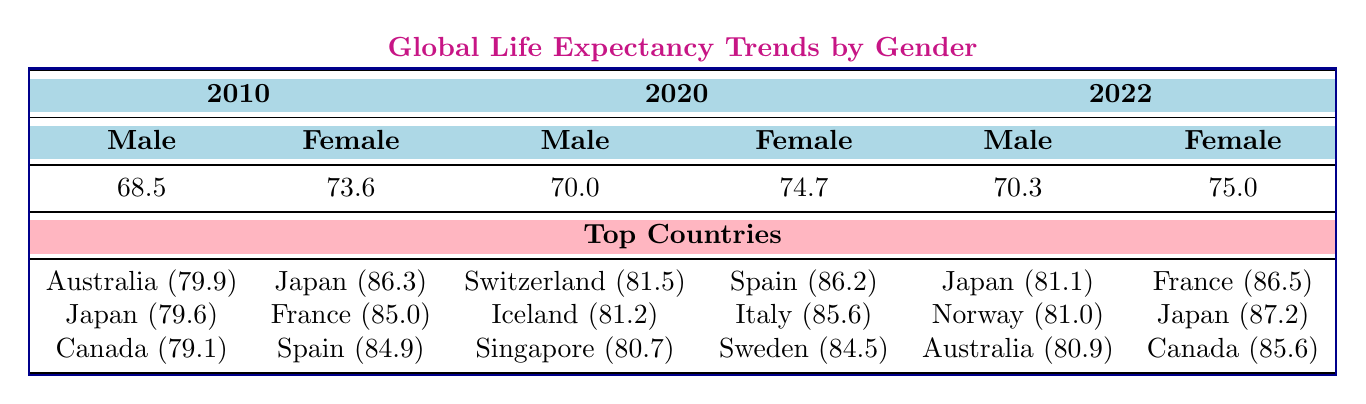What was the average life expectancy for males in 2020? Referring to the table, the value for average life expectancy for males in 2020 is 70.0.
Answer: 70.0 Which country had the highest life expectancy for females in 2022? Checking the top countries for females in 2022 from the table, Japan had the highest life expectancy of 87.2.
Answer: Japan What is the difference in average life expectancy between males and females in 2010? In 2010, the average life expectancy for males is 68.5 and for females is 73.6. The difference is 73.6 - 68.5 = 5.1.
Answer: 5.1 True or False: Singapore had a higher life expectancy than Canada for males in 2020. In 2020, Singapore's life expectancy for males is 80.7, while Canada's is not listed. So we can only deduce that Singapore's value exists. Therefore, it cannot be determined if it's higher or lower than Canada's.
Answer: False Which gender showed a greater increase in average life expectancy from 2010 to 2022? The average life expectancy for males increased from 68.5 in 2010 to 70.3 in 2022, which is an increase of 1.8. For females, it increased from 73.6 in 2010 to 75.0 in 2022, which is an increase of 1.4. Comparing both increases, males had a greater increase.
Answer: Males What are the top three countries for males with the longest life expectancy in 2022? From the table, the top three countries with the longest male life expectancy in 2022 are Japan (81.1), Norway (81.0), and Australia (80.9).
Answer: Japan, Norway, Australia How much did the average life expectancy for females change from 2020 to 2022? For females, the average life expectancy in 2020 was 74.7 and in 2022 it was 75.0. The change is 75.0 - 74.7 = 0.3.
Answer: 0.3 In which year did the average life expectancy for females exceed 75 years? The average life expectancy for females first exceeds 75 years in 2022, as the 2020 value was 74.7.
Answer: 2022 True or False: Australia had a higher average life expectancy for males than females in any of the years listed. In all three years listed, the average life expectancy for males was always lower than for females. Therefore, the statement is false.
Answer: False 